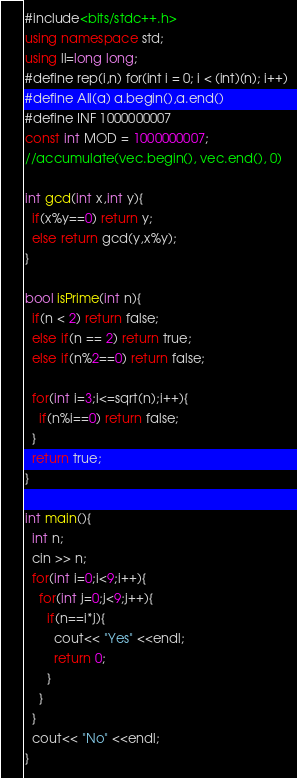Convert code to text. <code><loc_0><loc_0><loc_500><loc_500><_C++_>#include<bits/stdc++.h>
using namespace std;
using ll=long long;
#define rep(i,n) for(int i = 0; i < (int)(n); i++)
#define All(a) a.begin(),a.end()
#define INF 1000000007
const int MOD = 1000000007;
//accumulate(vec.begin(), vec.end(), 0)

int gcd(int x,int y){
  if(x%y==0) return y;
  else return gcd(y,x%y);
}

bool isPrime(int n){
  if(n < 2) return false;
  else if(n == 2) return true;
  else if(n%2==0) return false;

  for(int i=3;i<=sqrt(n);i++){
    if(n%i==0) return false;
  }
  return true;
}

int main(){
  int n;
  cin >> n;
  for(int i=0;i<9;i++){
    for(int j=0;j<9;j++){
      if(n==i*j){
        cout<< "Yes" <<endl;
        return 0;
      }
    }
  }
  cout<< "No" <<endl;
}
</code> 